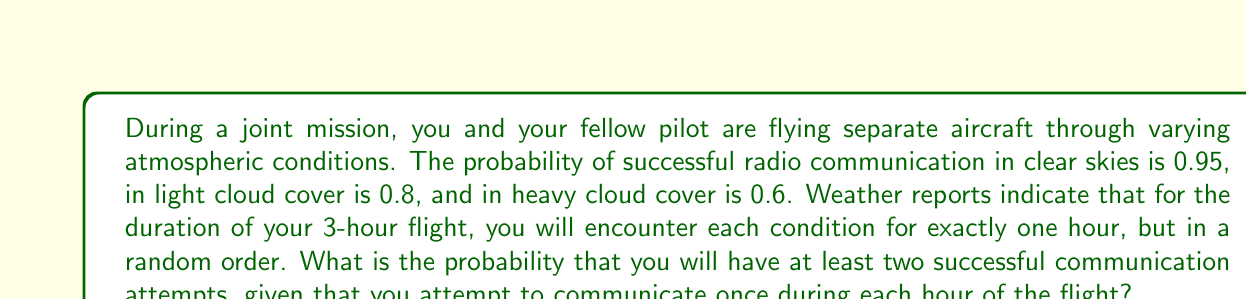What is the answer to this math problem? Let's approach this step-by-step:

1) First, we need to recognize that this is a binomial probability problem with $n=3$ trials (3 hours) and varying probabilities of success for each trial.

2) Let's define success as having at least two successful communication attempts out of three.

3) We can calculate this by finding the probability of exactly 2 successes plus the probability of exactly 3 successes.

4) To do this, we need to consider all possible orders of atmospheric conditions:
   - Clear (C), Light (L), Heavy (H)
   - C, H, L
   - L, C, H
   - L, H, C
   - H, C, L
   - H, L, C

5) For each order, we calculate the probability of 2 or 3 successes:

   P(2 or 3 successes) = P(2 successes) + P(3 successes)
   
   $$P(2\text{ or }3) = \binom{3}{2}p_1p_2(1-p_3) + \binom{3}{3}p_1p_2p_3$$

   where $p_1$, $p_2$, and $p_3$ are the probabilities of success in each hour.

6) For example, for the order C, L, H:
   $$P(2\text{ or }3) = 3(0.95)(0.8)(1-0.6) + (0.95)(0.8)(0.6) = 0.912$$

7) We calculate this for all 6 possible orders:
   C, L, H: 0.912
   C, H, L: 0.912
   L, C, H: 0.912
   L, H, C: 0.912
   H, C, L: 0.912
   H, L, C: 0.912

8) Since all orders have the same probability and are equally likely, the final probability is also 0.912.
Answer: 0.912 